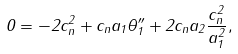Convert formula to latex. <formula><loc_0><loc_0><loc_500><loc_500>0 = - 2 c _ { n } ^ { 2 } + c _ { n } a _ { 1 } \theta _ { 1 } ^ { \prime \prime } + 2 c _ { n } a _ { 2 } \frac { c _ { n } ^ { 2 } } { a _ { 1 } ^ { 2 } } ,</formula> 